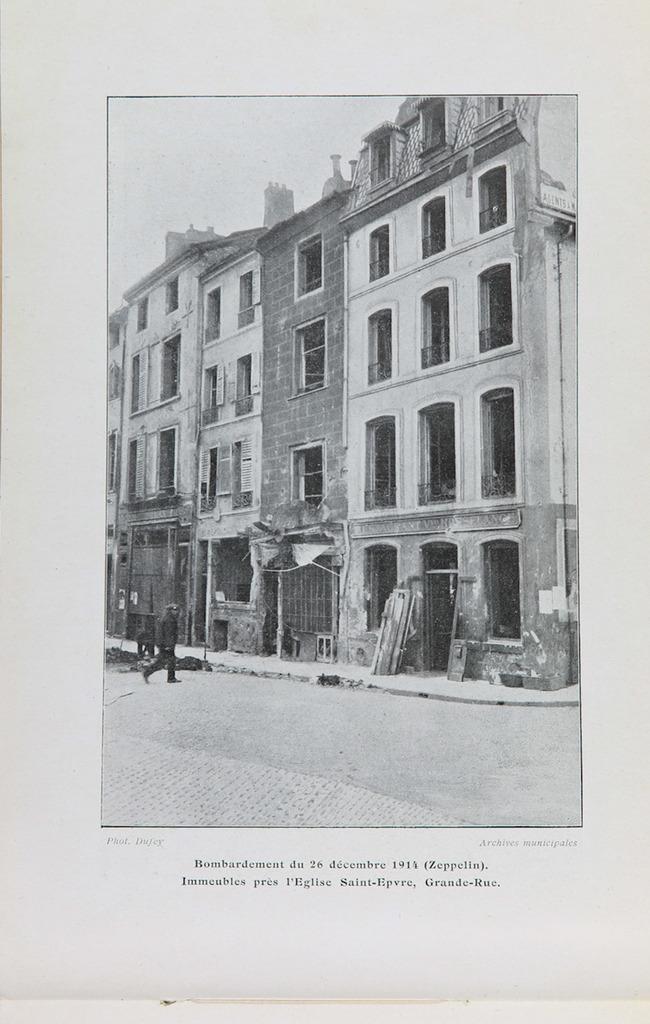Can you describe this image briefly? In the image we can see there is a poster on which a person is standing on the road and there is a building. The image is in black and white colour. 